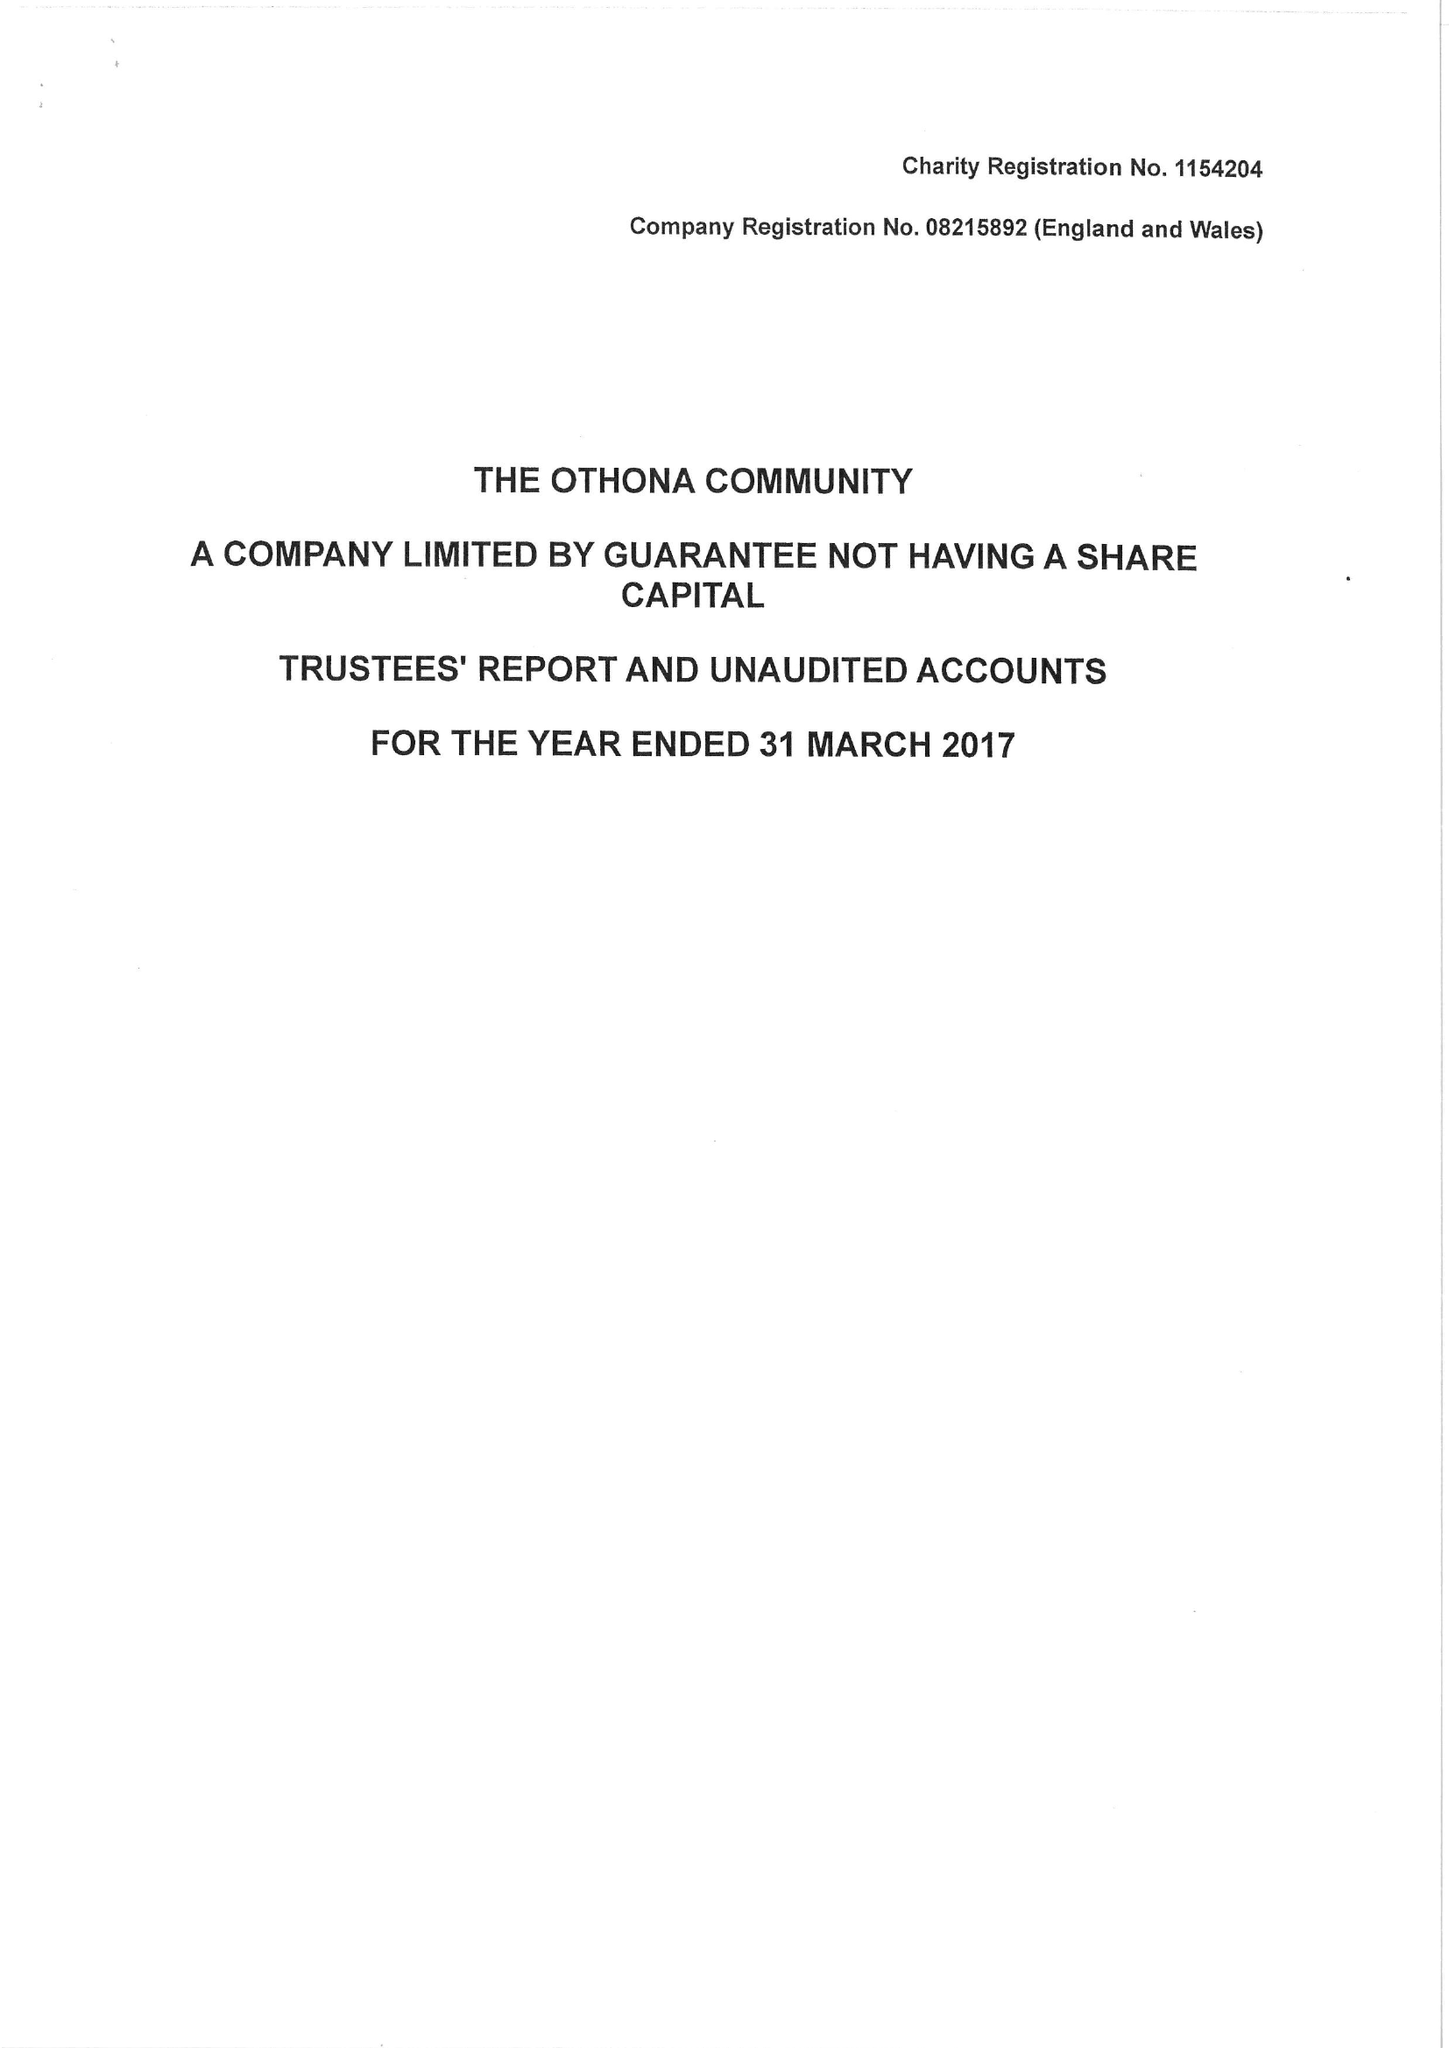What is the value for the income_annually_in_british_pounds?
Answer the question using a single word or phrase. 283417.00 